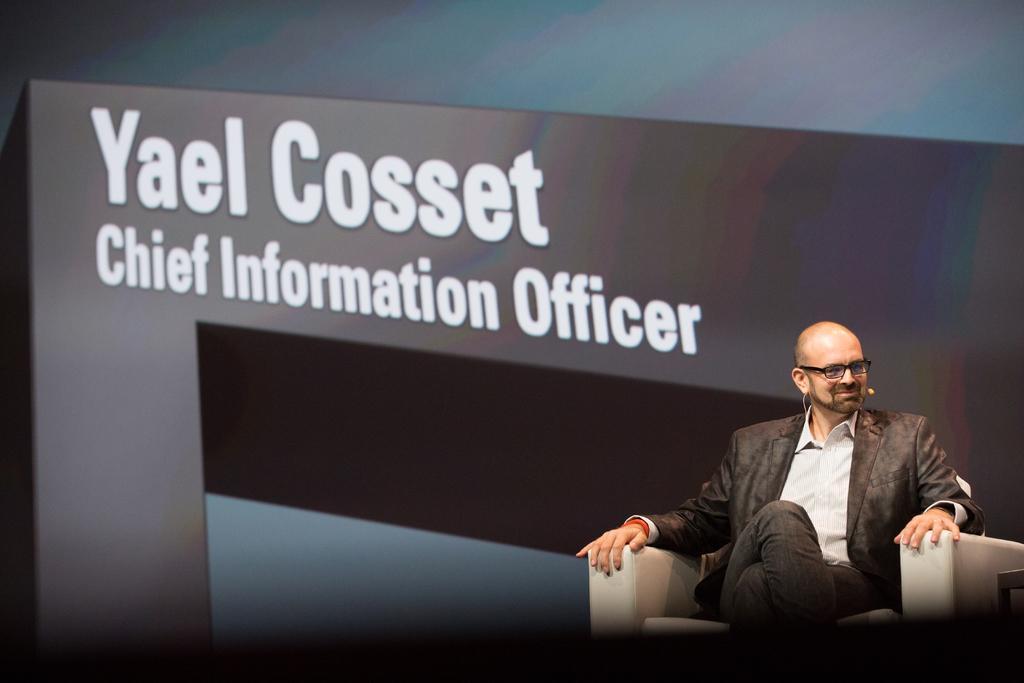Could you give a brief overview of what you see in this image? In this picture we can see a man wore a blazer, spectacle and sitting on a chair and smiling and in the background we can see a banner. 